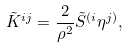Convert formula to latex. <formula><loc_0><loc_0><loc_500><loc_500>\tilde { K } ^ { i j } = \frac { 2 } { \rho ^ { 2 } } \tilde { S } ^ { ( i } \eta ^ { j ) } ,</formula> 